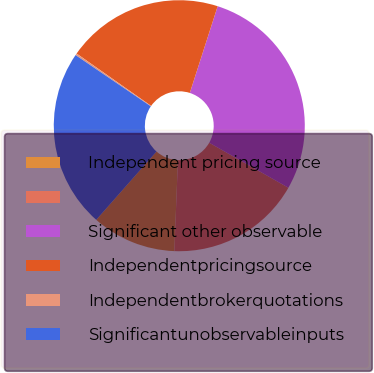<chart> <loc_0><loc_0><loc_500><loc_500><pie_chart><fcel>Independent pricing source<fcel>Unnamed: 1<fcel>Significant other observable<fcel>Independentpricingsource<fcel>Independentbrokerquotations<fcel>Significantunobservableinputs<nl><fcel>10.88%<fcel>17.4%<fcel>28.28%<fcel>20.2%<fcel>0.23%<fcel>23.01%<nl></chart> 